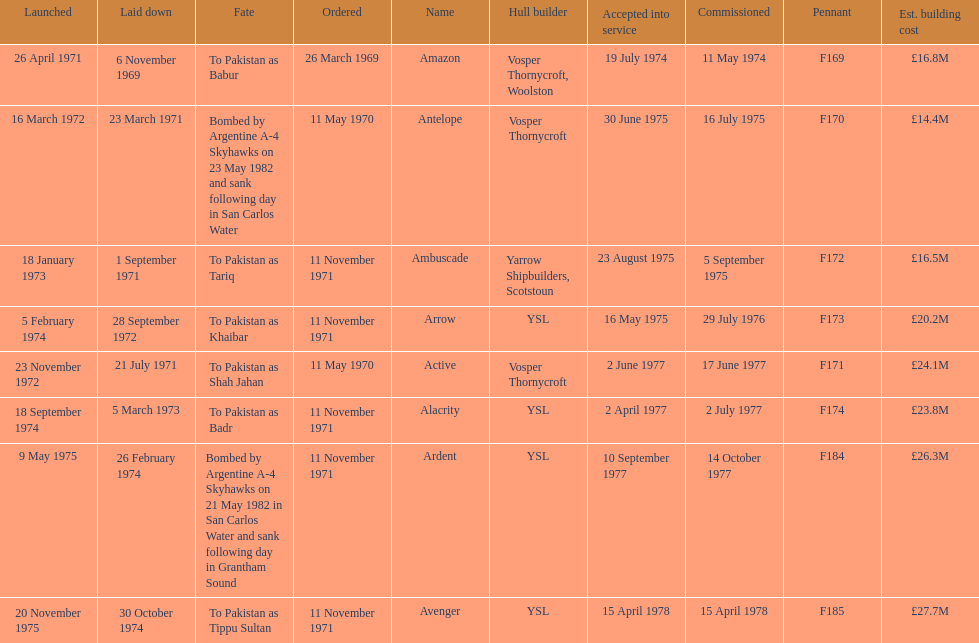What is the last listed pennant? F185. 